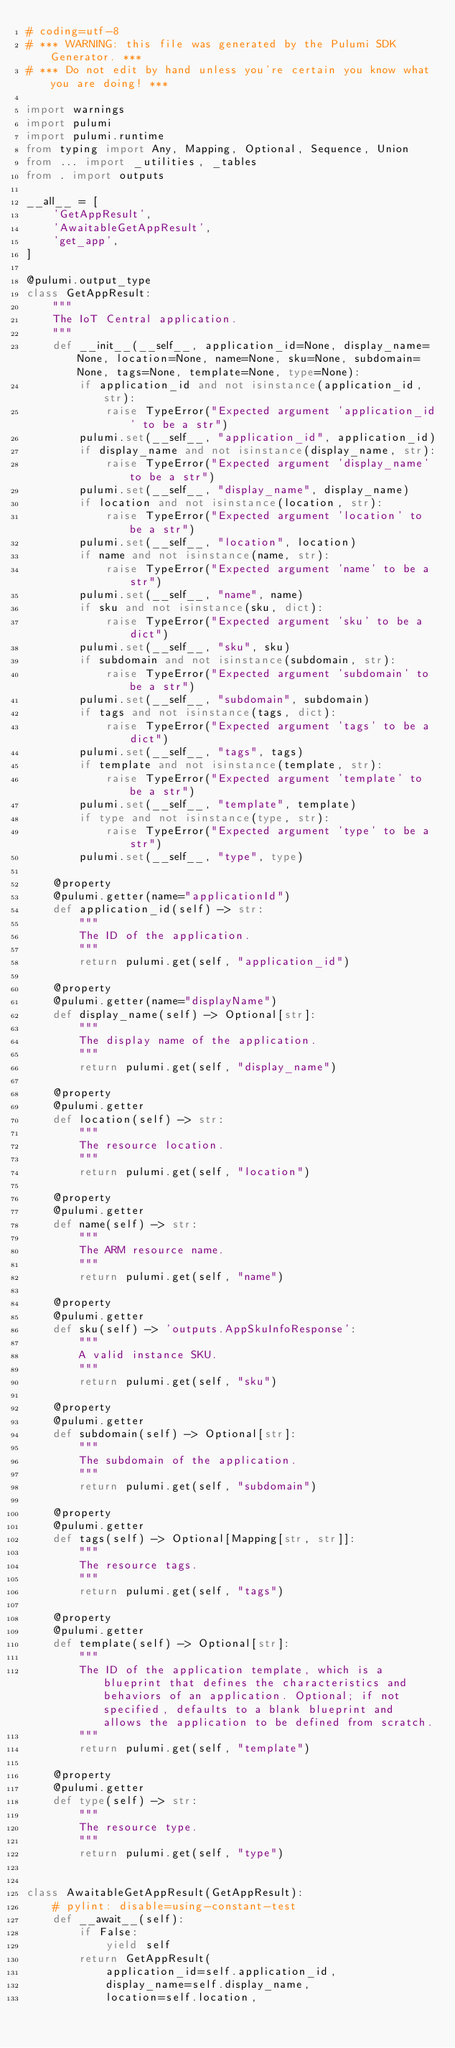Convert code to text. <code><loc_0><loc_0><loc_500><loc_500><_Python_># coding=utf-8
# *** WARNING: this file was generated by the Pulumi SDK Generator. ***
# *** Do not edit by hand unless you're certain you know what you are doing! ***

import warnings
import pulumi
import pulumi.runtime
from typing import Any, Mapping, Optional, Sequence, Union
from ... import _utilities, _tables
from . import outputs

__all__ = [
    'GetAppResult',
    'AwaitableGetAppResult',
    'get_app',
]

@pulumi.output_type
class GetAppResult:
    """
    The IoT Central application.
    """
    def __init__(__self__, application_id=None, display_name=None, location=None, name=None, sku=None, subdomain=None, tags=None, template=None, type=None):
        if application_id and not isinstance(application_id, str):
            raise TypeError("Expected argument 'application_id' to be a str")
        pulumi.set(__self__, "application_id", application_id)
        if display_name and not isinstance(display_name, str):
            raise TypeError("Expected argument 'display_name' to be a str")
        pulumi.set(__self__, "display_name", display_name)
        if location and not isinstance(location, str):
            raise TypeError("Expected argument 'location' to be a str")
        pulumi.set(__self__, "location", location)
        if name and not isinstance(name, str):
            raise TypeError("Expected argument 'name' to be a str")
        pulumi.set(__self__, "name", name)
        if sku and not isinstance(sku, dict):
            raise TypeError("Expected argument 'sku' to be a dict")
        pulumi.set(__self__, "sku", sku)
        if subdomain and not isinstance(subdomain, str):
            raise TypeError("Expected argument 'subdomain' to be a str")
        pulumi.set(__self__, "subdomain", subdomain)
        if tags and not isinstance(tags, dict):
            raise TypeError("Expected argument 'tags' to be a dict")
        pulumi.set(__self__, "tags", tags)
        if template and not isinstance(template, str):
            raise TypeError("Expected argument 'template' to be a str")
        pulumi.set(__self__, "template", template)
        if type and not isinstance(type, str):
            raise TypeError("Expected argument 'type' to be a str")
        pulumi.set(__self__, "type", type)

    @property
    @pulumi.getter(name="applicationId")
    def application_id(self) -> str:
        """
        The ID of the application.
        """
        return pulumi.get(self, "application_id")

    @property
    @pulumi.getter(name="displayName")
    def display_name(self) -> Optional[str]:
        """
        The display name of the application.
        """
        return pulumi.get(self, "display_name")

    @property
    @pulumi.getter
    def location(self) -> str:
        """
        The resource location.
        """
        return pulumi.get(self, "location")

    @property
    @pulumi.getter
    def name(self) -> str:
        """
        The ARM resource name.
        """
        return pulumi.get(self, "name")

    @property
    @pulumi.getter
    def sku(self) -> 'outputs.AppSkuInfoResponse':
        """
        A valid instance SKU.
        """
        return pulumi.get(self, "sku")

    @property
    @pulumi.getter
    def subdomain(self) -> Optional[str]:
        """
        The subdomain of the application.
        """
        return pulumi.get(self, "subdomain")

    @property
    @pulumi.getter
    def tags(self) -> Optional[Mapping[str, str]]:
        """
        The resource tags.
        """
        return pulumi.get(self, "tags")

    @property
    @pulumi.getter
    def template(self) -> Optional[str]:
        """
        The ID of the application template, which is a blueprint that defines the characteristics and behaviors of an application. Optional; if not specified, defaults to a blank blueprint and allows the application to be defined from scratch.
        """
        return pulumi.get(self, "template")

    @property
    @pulumi.getter
    def type(self) -> str:
        """
        The resource type.
        """
        return pulumi.get(self, "type")


class AwaitableGetAppResult(GetAppResult):
    # pylint: disable=using-constant-test
    def __await__(self):
        if False:
            yield self
        return GetAppResult(
            application_id=self.application_id,
            display_name=self.display_name,
            location=self.location,</code> 